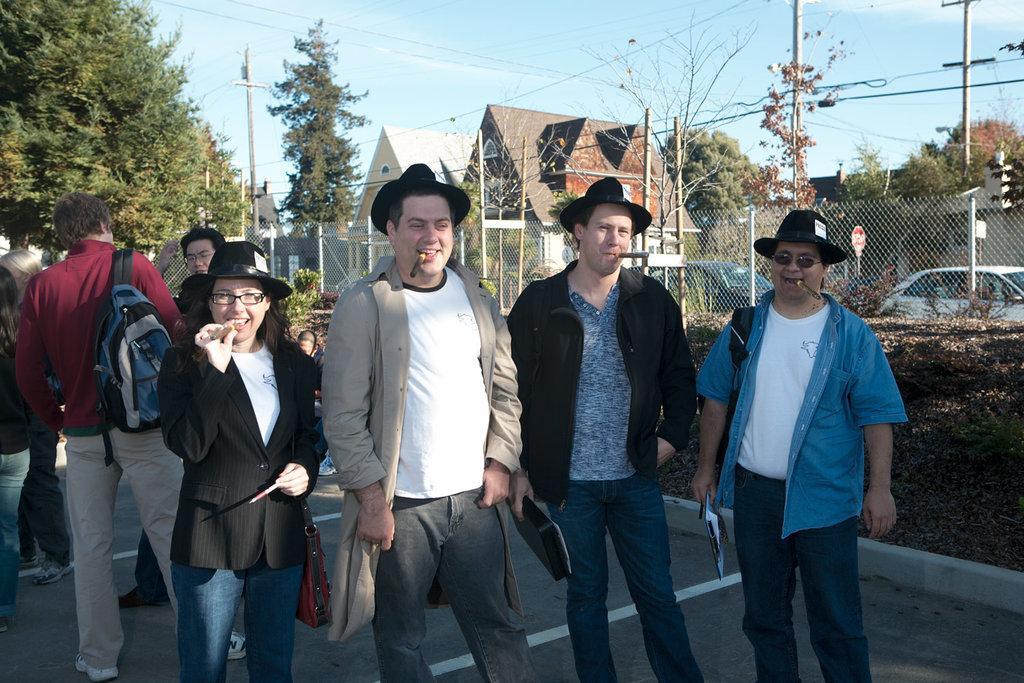In one or two sentences, can you explain what this image depicts? In this picture there are people in the center of the image and there are other people on the left side of the image, there are trees, cars, and houses in the background area of the image. 